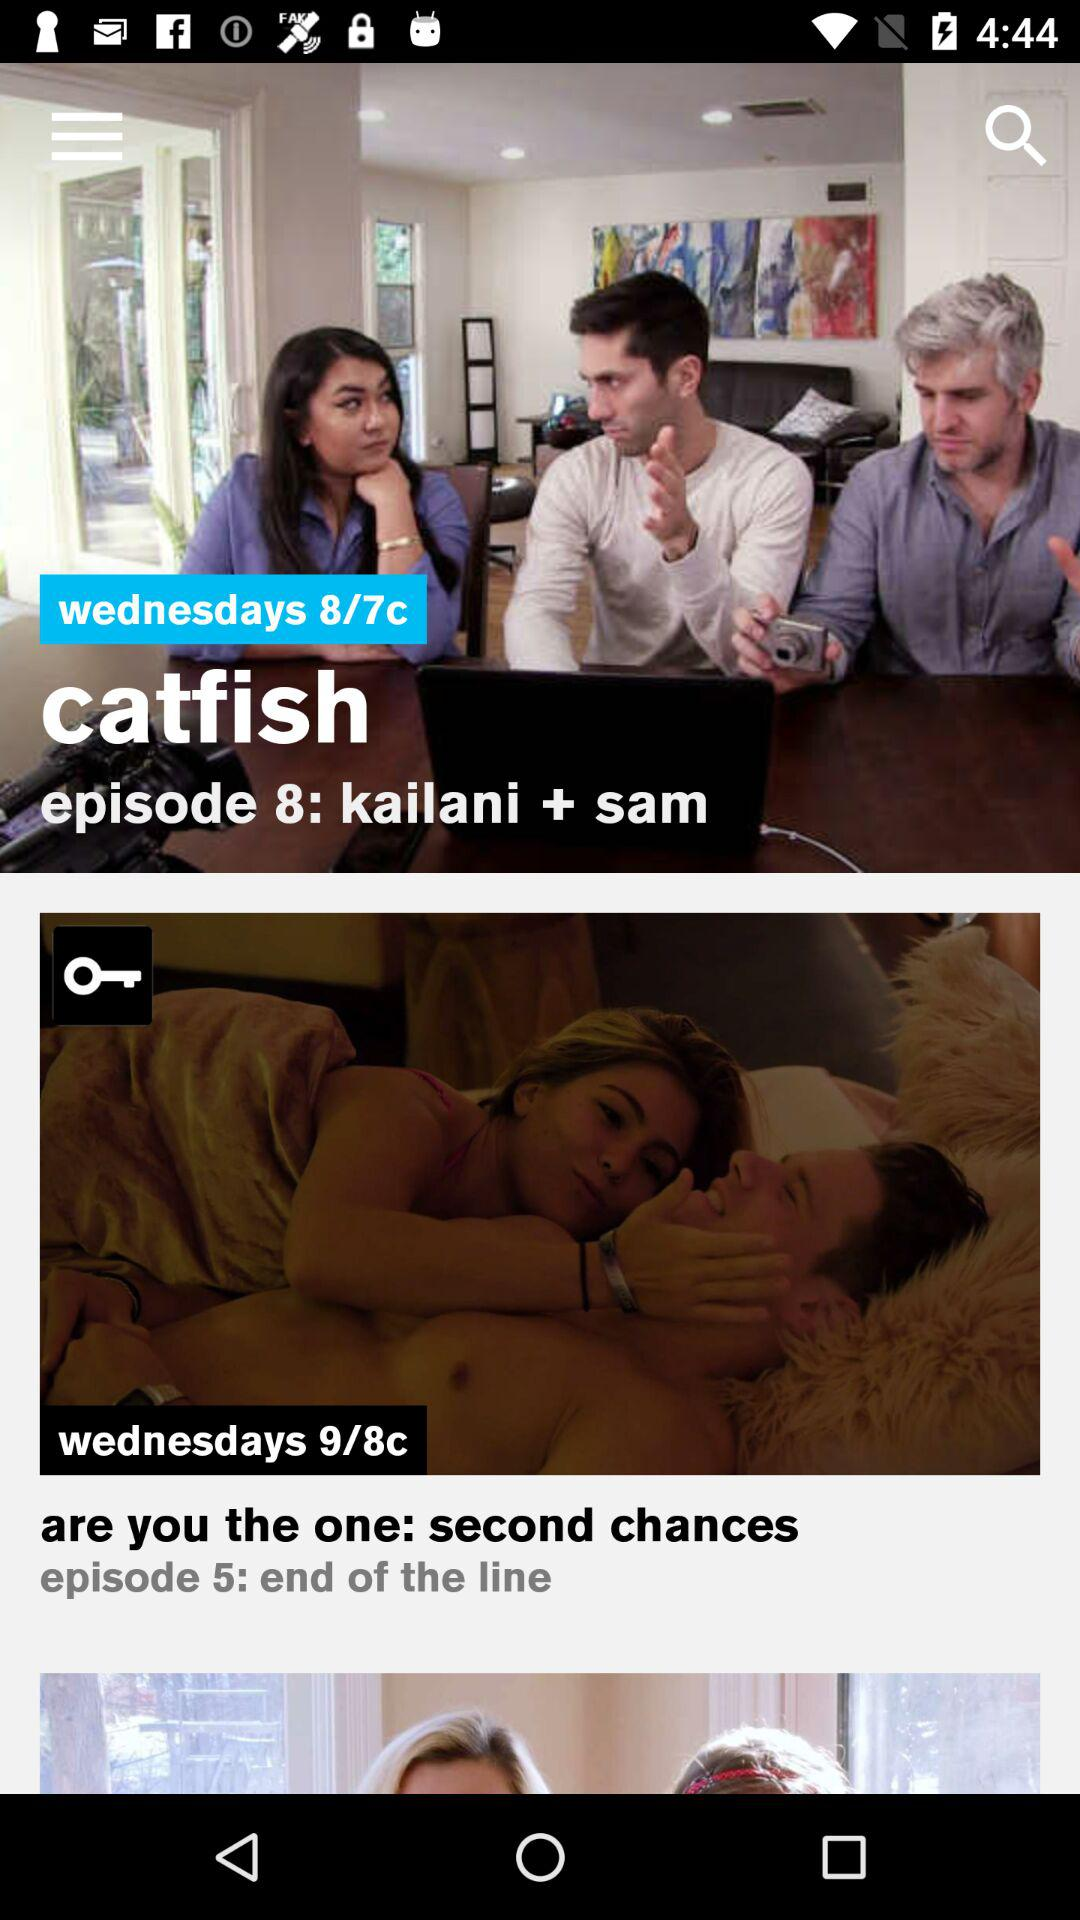What is the name of episode 5? The name of episode 5 is "end of the line". 